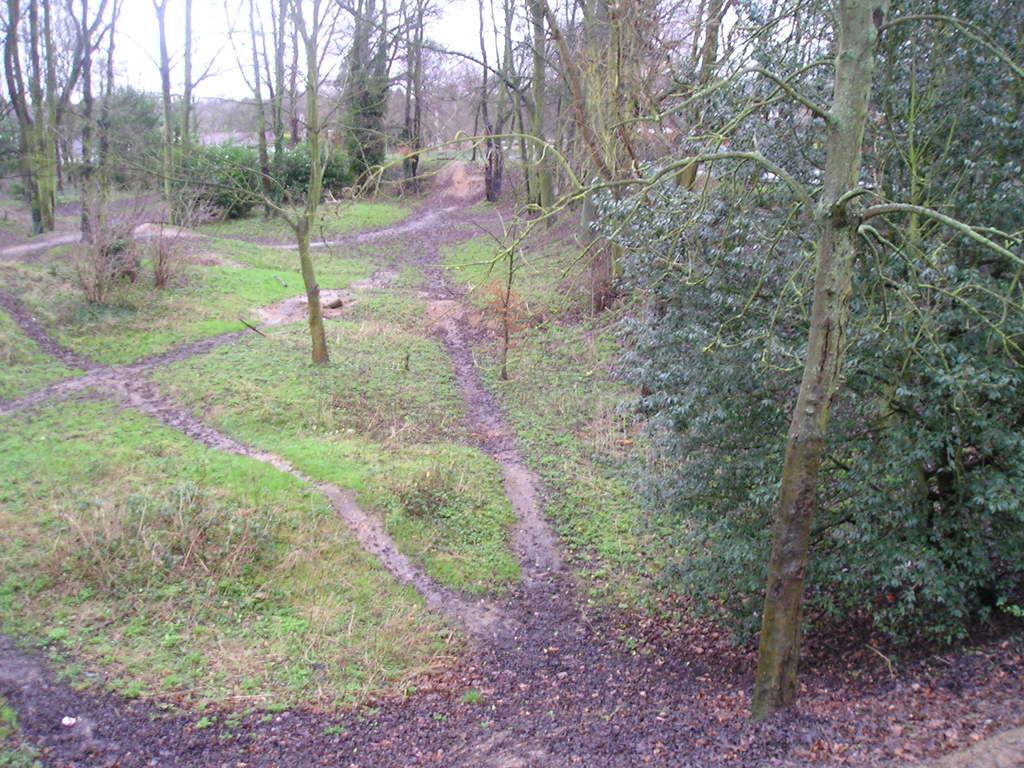What type of vegetation can be seen in the image? There are many trees, plants, and grass in the image. What part of the natural environment is visible in the image? The sky is visible in the background of the image. What type of jam is being spread on the blade in the image? There is no jam or blade present in the image; it features trees, plants, grass, and the sky. 